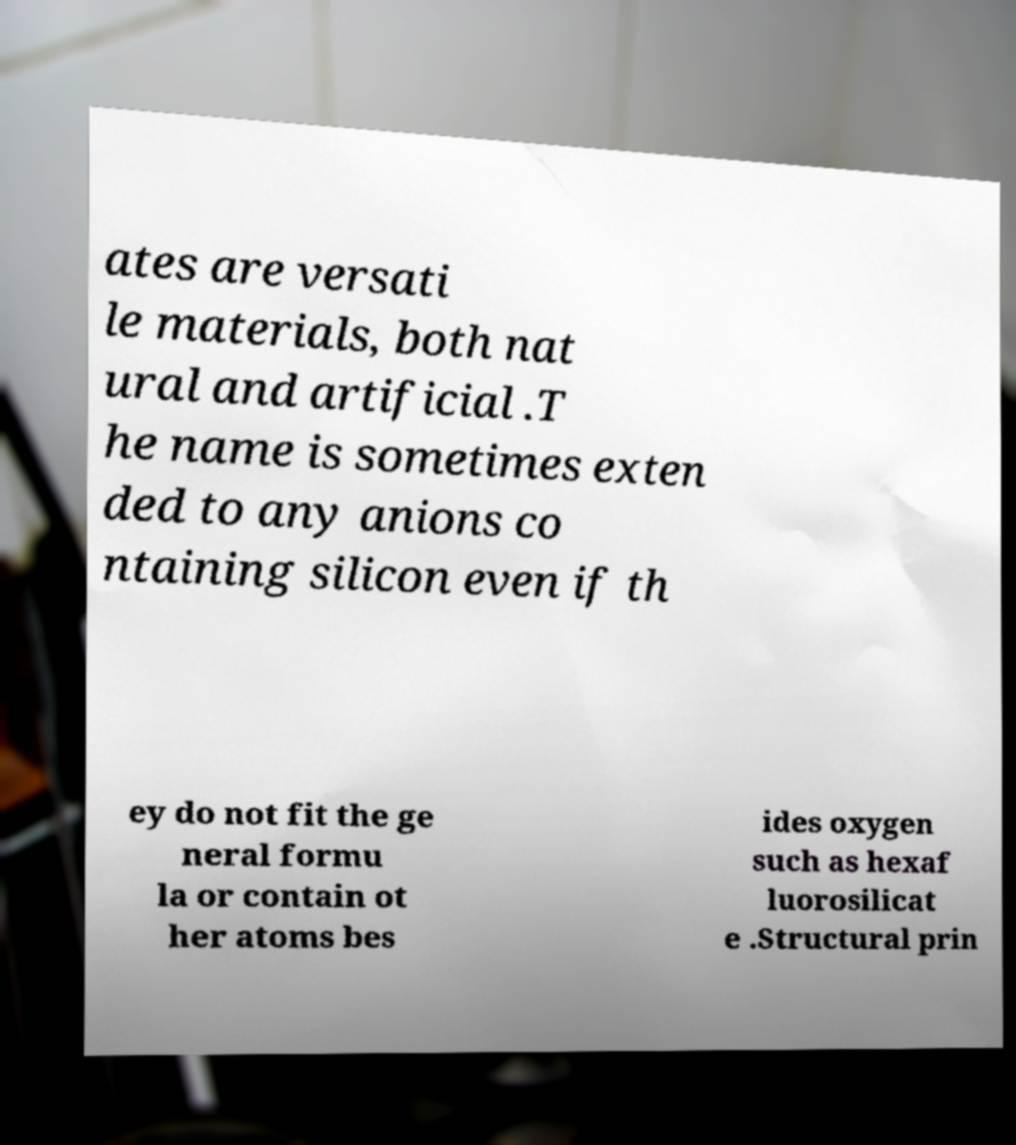Could you assist in decoding the text presented in this image and type it out clearly? ates are versati le materials, both nat ural and artificial .T he name is sometimes exten ded to any anions co ntaining silicon even if th ey do not fit the ge neral formu la or contain ot her atoms bes ides oxygen such as hexaf luorosilicat e .Structural prin 